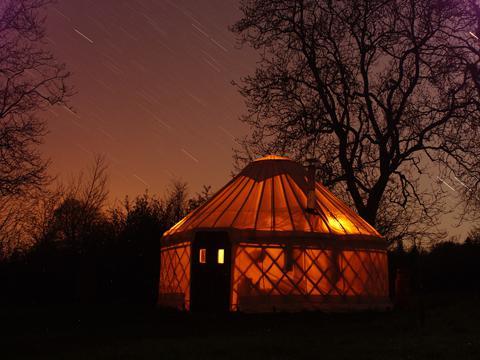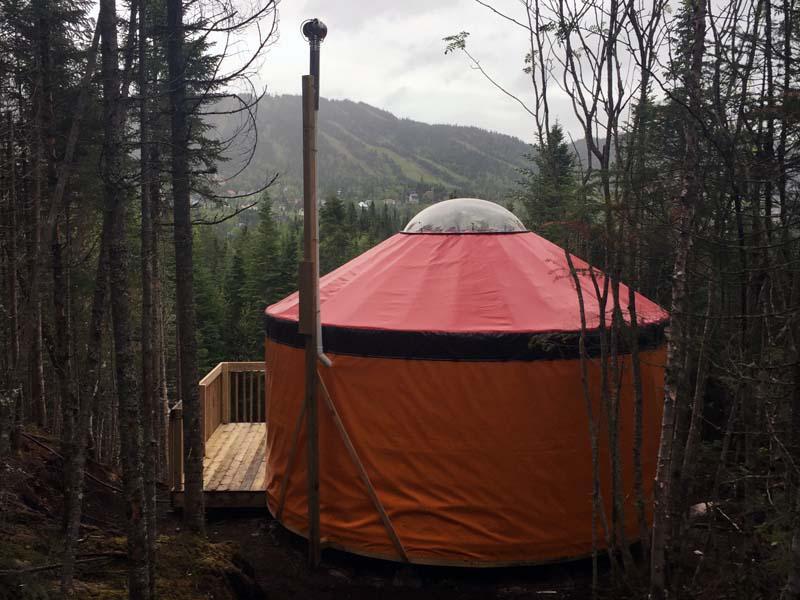The first image is the image on the left, the second image is the image on the right. For the images displayed, is the sentence "The crosshatched pattern of the wood structure is clearly visible in at least one of the images." factually correct? Answer yes or no. Yes. 